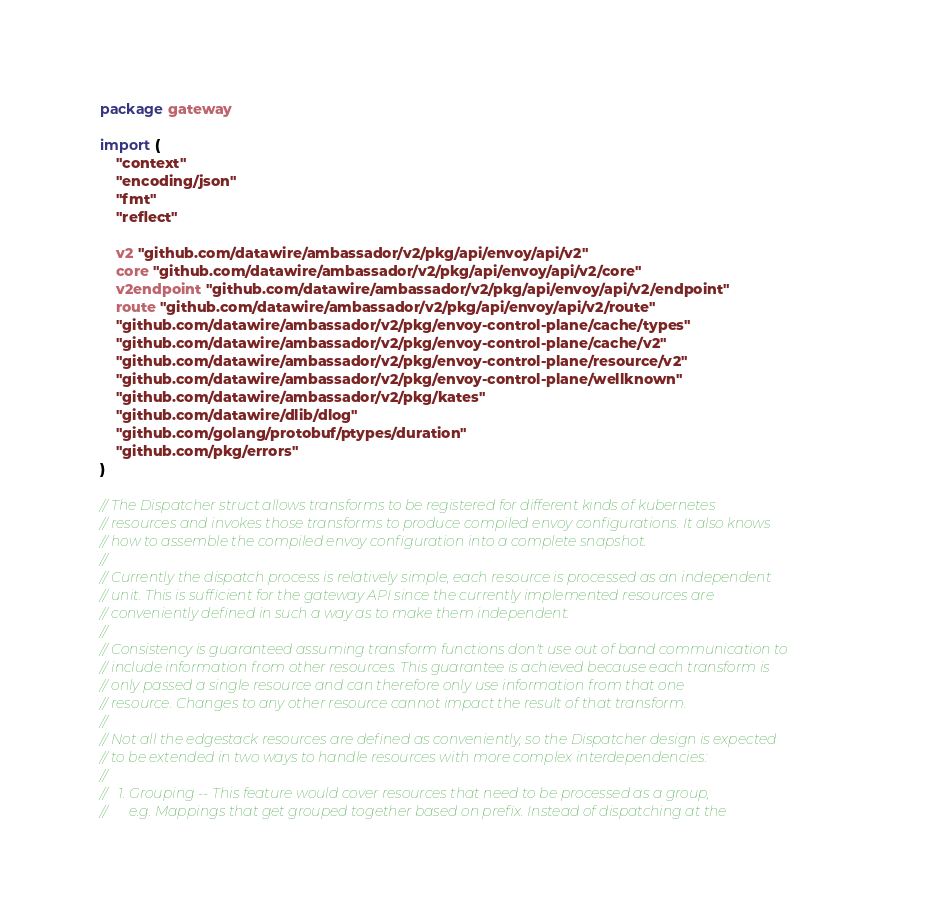Convert code to text. <code><loc_0><loc_0><loc_500><loc_500><_Go_>package gateway

import (
	"context"
	"encoding/json"
	"fmt"
	"reflect"

	v2 "github.com/datawire/ambassador/v2/pkg/api/envoy/api/v2"
	core "github.com/datawire/ambassador/v2/pkg/api/envoy/api/v2/core"
	v2endpoint "github.com/datawire/ambassador/v2/pkg/api/envoy/api/v2/endpoint"
	route "github.com/datawire/ambassador/v2/pkg/api/envoy/api/v2/route"
	"github.com/datawire/ambassador/v2/pkg/envoy-control-plane/cache/types"
	"github.com/datawire/ambassador/v2/pkg/envoy-control-plane/cache/v2"
	"github.com/datawire/ambassador/v2/pkg/envoy-control-plane/resource/v2"
	"github.com/datawire/ambassador/v2/pkg/envoy-control-plane/wellknown"
	"github.com/datawire/ambassador/v2/pkg/kates"
	"github.com/datawire/dlib/dlog"
	"github.com/golang/protobuf/ptypes/duration"
	"github.com/pkg/errors"
)

// The Dispatcher struct allows transforms to be registered for different kinds of kubernetes
// resources and invokes those transforms to produce compiled envoy configurations. It also knows
// how to assemble the compiled envoy configuration into a complete snapshot.
//
// Currently the dispatch process is relatively simple, each resource is processed as an independent
// unit. This is sufficient for the gateway API since the currently implemented resources are
// conveniently defined in such a way as to make them independent.
//
// Consistency is guaranteed assuming transform functions don't use out of band communication to
// include information from other resources. This guarantee is achieved because each transform is
// only passed a single resource and can therefore only use information from that one
// resource. Changes to any other resource cannot impact the result of that transform.
//
// Not all the edgestack resources are defined as conveniently, so the Dispatcher design is expected
// to be extended in two ways to handle resources with more complex interdependencies:
//
//   1. Grouping -- This feature would cover resources that need to be processed as a group,
//      e.g. Mappings that get grouped together based on prefix. Instead of dispatching at the</code> 